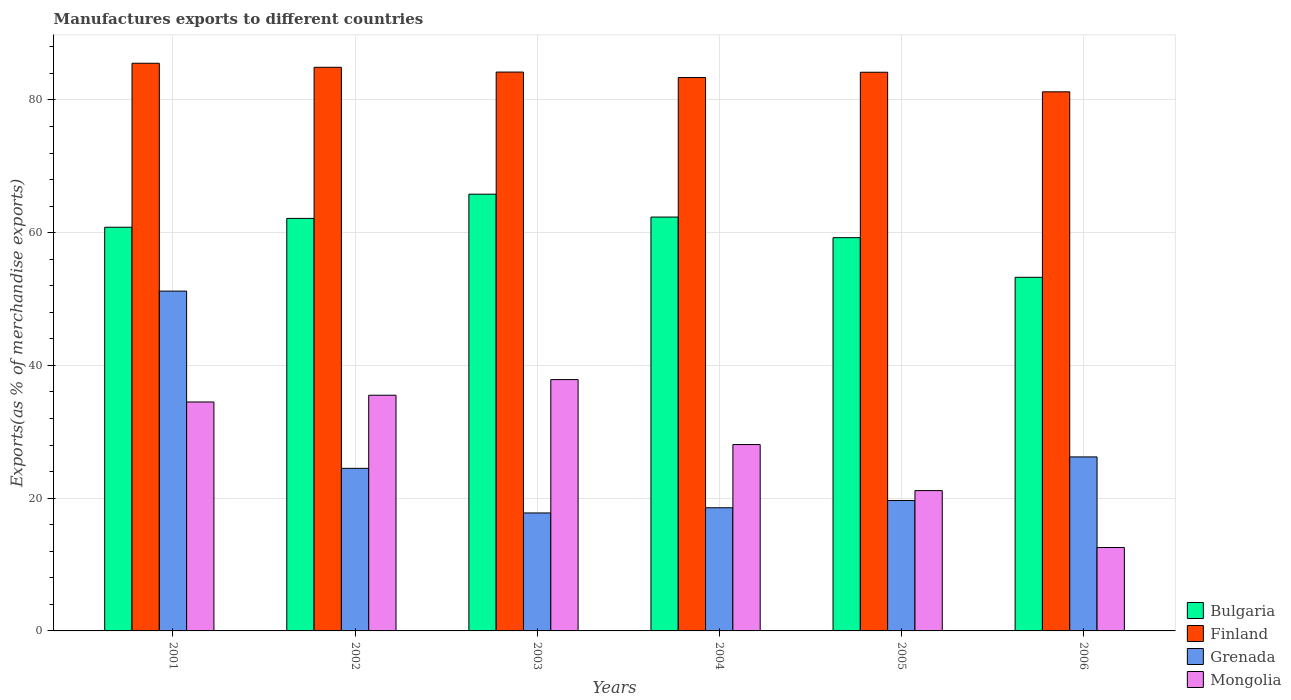How many different coloured bars are there?
Offer a terse response. 4. Are the number of bars per tick equal to the number of legend labels?
Your response must be concise. Yes. Are the number of bars on each tick of the X-axis equal?
Your answer should be very brief. Yes. How many bars are there on the 1st tick from the left?
Make the answer very short. 4. How many bars are there on the 6th tick from the right?
Offer a very short reply. 4. In how many cases, is the number of bars for a given year not equal to the number of legend labels?
Offer a very short reply. 0. What is the percentage of exports to different countries in Grenada in 2003?
Offer a very short reply. 17.77. Across all years, what is the maximum percentage of exports to different countries in Grenada?
Your answer should be compact. 51.2. Across all years, what is the minimum percentage of exports to different countries in Grenada?
Ensure brevity in your answer.  17.77. In which year was the percentage of exports to different countries in Bulgaria minimum?
Provide a succinct answer. 2006. What is the total percentage of exports to different countries in Mongolia in the graph?
Offer a very short reply. 169.65. What is the difference between the percentage of exports to different countries in Bulgaria in 2002 and that in 2006?
Provide a short and direct response. 8.88. What is the difference between the percentage of exports to different countries in Bulgaria in 2003 and the percentage of exports to different countries in Mongolia in 2002?
Your answer should be very brief. 30.29. What is the average percentage of exports to different countries in Finland per year?
Make the answer very short. 83.9. In the year 2002, what is the difference between the percentage of exports to different countries in Grenada and percentage of exports to different countries in Bulgaria?
Your answer should be compact. -37.66. What is the ratio of the percentage of exports to different countries in Finland in 2005 to that in 2006?
Provide a succinct answer. 1.04. Is the percentage of exports to different countries in Bulgaria in 2001 less than that in 2004?
Your answer should be compact. Yes. What is the difference between the highest and the second highest percentage of exports to different countries in Bulgaria?
Provide a succinct answer. 3.45. What is the difference between the highest and the lowest percentage of exports to different countries in Grenada?
Your answer should be compact. 33.42. In how many years, is the percentage of exports to different countries in Finland greater than the average percentage of exports to different countries in Finland taken over all years?
Your answer should be compact. 4. Is the sum of the percentage of exports to different countries in Finland in 2002 and 2003 greater than the maximum percentage of exports to different countries in Grenada across all years?
Offer a very short reply. Yes. Is it the case that in every year, the sum of the percentage of exports to different countries in Mongolia and percentage of exports to different countries in Grenada is greater than the sum of percentage of exports to different countries in Finland and percentage of exports to different countries in Bulgaria?
Your answer should be compact. No. What does the 3rd bar from the left in 2005 represents?
Provide a succinct answer. Grenada. Is it the case that in every year, the sum of the percentage of exports to different countries in Bulgaria and percentage of exports to different countries in Finland is greater than the percentage of exports to different countries in Mongolia?
Your answer should be compact. Yes. How many bars are there?
Offer a very short reply. 24. How many years are there in the graph?
Make the answer very short. 6. What is the difference between two consecutive major ticks on the Y-axis?
Your response must be concise. 20. Are the values on the major ticks of Y-axis written in scientific E-notation?
Give a very brief answer. No. Does the graph contain grids?
Provide a short and direct response. Yes. Where does the legend appear in the graph?
Make the answer very short. Bottom right. How many legend labels are there?
Your answer should be compact. 4. What is the title of the graph?
Offer a terse response. Manufactures exports to different countries. What is the label or title of the Y-axis?
Offer a very short reply. Exports(as % of merchandise exports). What is the Exports(as % of merchandise exports) in Bulgaria in 2001?
Your answer should be compact. 60.82. What is the Exports(as % of merchandise exports) in Finland in 2001?
Keep it short and to the point. 85.52. What is the Exports(as % of merchandise exports) of Grenada in 2001?
Your answer should be compact. 51.2. What is the Exports(as % of merchandise exports) in Mongolia in 2001?
Provide a succinct answer. 34.49. What is the Exports(as % of merchandise exports) of Bulgaria in 2002?
Ensure brevity in your answer.  62.15. What is the Exports(as % of merchandise exports) of Finland in 2002?
Provide a succinct answer. 84.92. What is the Exports(as % of merchandise exports) of Grenada in 2002?
Offer a terse response. 24.49. What is the Exports(as % of merchandise exports) in Mongolia in 2002?
Ensure brevity in your answer.  35.51. What is the Exports(as % of merchandise exports) of Bulgaria in 2003?
Offer a very short reply. 65.8. What is the Exports(as % of merchandise exports) of Finland in 2003?
Offer a very short reply. 84.2. What is the Exports(as % of merchandise exports) of Grenada in 2003?
Provide a short and direct response. 17.77. What is the Exports(as % of merchandise exports) in Mongolia in 2003?
Give a very brief answer. 37.86. What is the Exports(as % of merchandise exports) in Bulgaria in 2004?
Offer a very short reply. 62.35. What is the Exports(as % of merchandise exports) of Finland in 2004?
Ensure brevity in your answer.  83.37. What is the Exports(as % of merchandise exports) of Grenada in 2004?
Offer a very short reply. 18.56. What is the Exports(as % of merchandise exports) in Mongolia in 2004?
Ensure brevity in your answer.  28.08. What is the Exports(as % of merchandise exports) in Bulgaria in 2005?
Offer a terse response. 59.25. What is the Exports(as % of merchandise exports) in Finland in 2005?
Keep it short and to the point. 84.17. What is the Exports(as % of merchandise exports) in Grenada in 2005?
Ensure brevity in your answer.  19.65. What is the Exports(as % of merchandise exports) of Mongolia in 2005?
Provide a succinct answer. 21.14. What is the Exports(as % of merchandise exports) in Bulgaria in 2006?
Your answer should be very brief. 53.27. What is the Exports(as % of merchandise exports) in Finland in 2006?
Make the answer very short. 81.22. What is the Exports(as % of merchandise exports) in Grenada in 2006?
Give a very brief answer. 26.21. What is the Exports(as % of merchandise exports) of Mongolia in 2006?
Give a very brief answer. 12.57. Across all years, what is the maximum Exports(as % of merchandise exports) of Bulgaria?
Provide a succinct answer. 65.8. Across all years, what is the maximum Exports(as % of merchandise exports) of Finland?
Make the answer very short. 85.52. Across all years, what is the maximum Exports(as % of merchandise exports) in Grenada?
Give a very brief answer. 51.2. Across all years, what is the maximum Exports(as % of merchandise exports) in Mongolia?
Offer a very short reply. 37.86. Across all years, what is the minimum Exports(as % of merchandise exports) of Bulgaria?
Offer a very short reply. 53.27. Across all years, what is the minimum Exports(as % of merchandise exports) in Finland?
Make the answer very short. 81.22. Across all years, what is the minimum Exports(as % of merchandise exports) of Grenada?
Your answer should be very brief. 17.77. Across all years, what is the minimum Exports(as % of merchandise exports) in Mongolia?
Ensure brevity in your answer.  12.57. What is the total Exports(as % of merchandise exports) of Bulgaria in the graph?
Keep it short and to the point. 363.63. What is the total Exports(as % of merchandise exports) in Finland in the graph?
Ensure brevity in your answer.  503.4. What is the total Exports(as % of merchandise exports) in Grenada in the graph?
Make the answer very short. 157.88. What is the total Exports(as % of merchandise exports) in Mongolia in the graph?
Your answer should be compact. 169.65. What is the difference between the Exports(as % of merchandise exports) of Bulgaria in 2001 and that in 2002?
Provide a succinct answer. -1.33. What is the difference between the Exports(as % of merchandise exports) in Finland in 2001 and that in 2002?
Your answer should be very brief. 0.61. What is the difference between the Exports(as % of merchandise exports) of Grenada in 2001 and that in 2002?
Your answer should be compact. 26.7. What is the difference between the Exports(as % of merchandise exports) in Mongolia in 2001 and that in 2002?
Offer a very short reply. -1.02. What is the difference between the Exports(as % of merchandise exports) of Bulgaria in 2001 and that in 2003?
Offer a very short reply. -4.98. What is the difference between the Exports(as % of merchandise exports) in Finland in 2001 and that in 2003?
Your answer should be compact. 1.33. What is the difference between the Exports(as % of merchandise exports) in Grenada in 2001 and that in 2003?
Offer a very short reply. 33.42. What is the difference between the Exports(as % of merchandise exports) in Mongolia in 2001 and that in 2003?
Ensure brevity in your answer.  -3.37. What is the difference between the Exports(as % of merchandise exports) of Bulgaria in 2001 and that in 2004?
Your response must be concise. -1.53. What is the difference between the Exports(as % of merchandise exports) in Finland in 2001 and that in 2004?
Provide a short and direct response. 2.15. What is the difference between the Exports(as % of merchandise exports) in Grenada in 2001 and that in 2004?
Ensure brevity in your answer.  32.64. What is the difference between the Exports(as % of merchandise exports) in Mongolia in 2001 and that in 2004?
Provide a short and direct response. 6.41. What is the difference between the Exports(as % of merchandise exports) of Bulgaria in 2001 and that in 2005?
Your answer should be compact. 1.57. What is the difference between the Exports(as % of merchandise exports) of Finland in 2001 and that in 2005?
Your answer should be very brief. 1.35. What is the difference between the Exports(as % of merchandise exports) in Grenada in 2001 and that in 2005?
Give a very brief answer. 31.55. What is the difference between the Exports(as % of merchandise exports) in Mongolia in 2001 and that in 2005?
Make the answer very short. 13.35. What is the difference between the Exports(as % of merchandise exports) in Bulgaria in 2001 and that in 2006?
Keep it short and to the point. 7.54. What is the difference between the Exports(as % of merchandise exports) of Finland in 2001 and that in 2006?
Your answer should be very brief. 4.3. What is the difference between the Exports(as % of merchandise exports) of Grenada in 2001 and that in 2006?
Your response must be concise. 24.98. What is the difference between the Exports(as % of merchandise exports) of Mongolia in 2001 and that in 2006?
Provide a succinct answer. 21.93. What is the difference between the Exports(as % of merchandise exports) of Bulgaria in 2002 and that in 2003?
Offer a terse response. -3.65. What is the difference between the Exports(as % of merchandise exports) in Finland in 2002 and that in 2003?
Your answer should be very brief. 0.72. What is the difference between the Exports(as % of merchandise exports) of Grenada in 2002 and that in 2003?
Offer a terse response. 6.72. What is the difference between the Exports(as % of merchandise exports) in Mongolia in 2002 and that in 2003?
Ensure brevity in your answer.  -2.35. What is the difference between the Exports(as % of merchandise exports) in Bulgaria in 2002 and that in 2004?
Keep it short and to the point. -0.2. What is the difference between the Exports(as % of merchandise exports) in Finland in 2002 and that in 2004?
Keep it short and to the point. 1.54. What is the difference between the Exports(as % of merchandise exports) in Grenada in 2002 and that in 2004?
Your answer should be compact. 5.94. What is the difference between the Exports(as % of merchandise exports) of Mongolia in 2002 and that in 2004?
Ensure brevity in your answer.  7.43. What is the difference between the Exports(as % of merchandise exports) in Bulgaria in 2002 and that in 2005?
Make the answer very short. 2.9. What is the difference between the Exports(as % of merchandise exports) in Finland in 2002 and that in 2005?
Provide a short and direct response. 0.75. What is the difference between the Exports(as % of merchandise exports) in Grenada in 2002 and that in 2005?
Keep it short and to the point. 4.85. What is the difference between the Exports(as % of merchandise exports) of Mongolia in 2002 and that in 2005?
Provide a succinct answer. 14.37. What is the difference between the Exports(as % of merchandise exports) of Bulgaria in 2002 and that in 2006?
Make the answer very short. 8.88. What is the difference between the Exports(as % of merchandise exports) in Finland in 2002 and that in 2006?
Your answer should be very brief. 3.7. What is the difference between the Exports(as % of merchandise exports) in Grenada in 2002 and that in 2006?
Your response must be concise. -1.72. What is the difference between the Exports(as % of merchandise exports) of Mongolia in 2002 and that in 2006?
Offer a terse response. 22.94. What is the difference between the Exports(as % of merchandise exports) of Bulgaria in 2003 and that in 2004?
Give a very brief answer. 3.45. What is the difference between the Exports(as % of merchandise exports) of Finland in 2003 and that in 2004?
Keep it short and to the point. 0.82. What is the difference between the Exports(as % of merchandise exports) in Grenada in 2003 and that in 2004?
Your answer should be very brief. -0.78. What is the difference between the Exports(as % of merchandise exports) of Mongolia in 2003 and that in 2004?
Your answer should be very brief. 9.78. What is the difference between the Exports(as % of merchandise exports) of Bulgaria in 2003 and that in 2005?
Your answer should be very brief. 6.55. What is the difference between the Exports(as % of merchandise exports) of Finland in 2003 and that in 2005?
Your answer should be compact. 0.03. What is the difference between the Exports(as % of merchandise exports) of Grenada in 2003 and that in 2005?
Your answer should be very brief. -1.87. What is the difference between the Exports(as % of merchandise exports) of Mongolia in 2003 and that in 2005?
Your answer should be very brief. 16.72. What is the difference between the Exports(as % of merchandise exports) in Bulgaria in 2003 and that in 2006?
Your response must be concise. 12.52. What is the difference between the Exports(as % of merchandise exports) of Finland in 2003 and that in 2006?
Keep it short and to the point. 2.98. What is the difference between the Exports(as % of merchandise exports) of Grenada in 2003 and that in 2006?
Your response must be concise. -8.44. What is the difference between the Exports(as % of merchandise exports) in Mongolia in 2003 and that in 2006?
Keep it short and to the point. 25.3. What is the difference between the Exports(as % of merchandise exports) in Bulgaria in 2004 and that in 2005?
Your response must be concise. 3.1. What is the difference between the Exports(as % of merchandise exports) in Finland in 2004 and that in 2005?
Ensure brevity in your answer.  -0.8. What is the difference between the Exports(as % of merchandise exports) of Grenada in 2004 and that in 2005?
Offer a very short reply. -1.09. What is the difference between the Exports(as % of merchandise exports) of Mongolia in 2004 and that in 2005?
Provide a short and direct response. 6.94. What is the difference between the Exports(as % of merchandise exports) of Bulgaria in 2004 and that in 2006?
Your response must be concise. 9.08. What is the difference between the Exports(as % of merchandise exports) of Finland in 2004 and that in 2006?
Provide a succinct answer. 2.15. What is the difference between the Exports(as % of merchandise exports) of Grenada in 2004 and that in 2006?
Provide a short and direct response. -7.66. What is the difference between the Exports(as % of merchandise exports) in Mongolia in 2004 and that in 2006?
Your answer should be very brief. 15.51. What is the difference between the Exports(as % of merchandise exports) in Bulgaria in 2005 and that in 2006?
Your answer should be very brief. 5.97. What is the difference between the Exports(as % of merchandise exports) in Finland in 2005 and that in 2006?
Provide a succinct answer. 2.95. What is the difference between the Exports(as % of merchandise exports) in Grenada in 2005 and that in 2006?
Provide a succinct answer. -6.57. What is the difference between the Exports(as % of merchandise exports) of Mongolia in 2005 and that in 2006?
Provide a short and direct response. 8.57. What is the difference between the Exports(as % of merchandise exports) of Bulgaria in 2001 and the Exports(as % of merchandise exports) of Finland in 2002?
Provide a succinct answer. -24.1. What is the difference between the Exports(as % of merchandise exports) of Bulgaria in 2001 and the Exports(as % of merchandise exports) of Grenada in 2002?
Keep it short and to the point. 36.32. What is the difference between the Exports(as % of merchandise exports) of Bulgaria in 2001 and the Exports(as % of merchandise exports) of Mongolia in 2002?
Give a very brief answer. 25.31. What is the difference between the Exports(as % of merchandise exports) in Finland in 2001 and the Exports(as % of merchandise exports) in Grenada in 2002?
Your response must be concise. 61.03. What is the difference between the Exports(as % of merchandise exports) in Finland in 2001 and the Exports(as % of merchandise exports) in Mongolia in 2002?
Keep it short and to the point. 50.01. What is the difference between the Exports(as % of merchandise exports) of Grenada in 2001 and the Exports(as % of merchandise exports) of Mongolia in 2002?
Offer a terse response. 15.69. What is the difference between the Exports(as % of merchandise exports) in Bulgaria in 2001 and the Exports(as % of merchandise exports) in Finland in 2003?
Provide a short and direct response. -23.38. What is the difference between the Exports(as % of merchandise exports) of Bulgaria in 2001 and the Exports(as % of merchandise exports) of Grenada in 2003?
Offer a very short reply. 43.04. What is the difference between the Exports(as % of merchandise exports) of Bulgaria in 2001 and the Exports(as % of merchandise exports) of Mongolia in 2003?
Provide a succinct answer. 22.95. What is the difference between the Exports(as % of merchandise exports) of Finland in 2001 and the Exports(as % of merchandise exports) of Grenada in 2003?
Make the answer very short. 67.75. What is the difference between the Exports(as % of merchandise exports) in Finland in 2001 and the Exports(as % of merchandise exports) in Mongolia in 2003?
Your answer should be compact. 47.66. What is the difference between the Exports(as % of merchandise exports) of Grenada in 2001 and the Exports(as % of merchandise exports) of Mongolia in 2003?
Your response must be concise. 13.33. What is the difference between the Exports(as % of merchandise exports) in Bulgaria in 2001 and the Exports(as % of merchandise exports) in Finland in 2004?
Your answer should be compact. -22.56. What is the difference between the Exports(as % of merchandise exports) in Bulgaria in 2001 and the Exports(as % of merchandise exports) in Grenada in 2004?
Keep it short and to the point. 42.26. What is the difference between the Exports(as % of merchandise exports) in Bulgaria in 2001 and the Exports(as % of merchandise exports) in Mongolia in 2004?
Offer a terse response. 32.74. What is the difference between the Exports(as % of merchandise exports) in Finland in 2001 and the Exports(as % of merchandise exports) in Grenada in 2004?
Offer a very short reply. 66.97. What is the difference between the Exports(as % of merchandise exports) of Finland in 2001 and the Exports(as % of merchandise exports) of Mongolia in 2004?
Ensure brevity in your answer.  57.44. What is the difference between the Exports(as % of merchandise exports) of Grenada in 2001 and the Exports(as % of merchandise exports) of Mongolia in 2004?
Keep it short and to the point. 23.12. What is the difference between the Exports(as % of merchandise exports) in Bulgaria in 2001 and the Exports(as % of merchandise exports) in Finland in 2005?
Your answer should be compact. -23.35. What is the difference between the Exports(as % of merchandise exports) in Bulgaria in 2001 and the Exports(as % of merchandise exports) in Grenada in 2005?
Keep it short and to the point. 41.17. What is the difference between the Exports(as % of merchandise exports) in Bulgaria in 2001 and the Exports(as % of merchandise exports) in Mongolia in 2005?
Offer a terse response. 39.68. What is the difference between the Exports(as % of merchandise exports) in Finland in 2001 and the Exports(as % of merchandise exports) in Grenada in 2005?
Keep it short and to the point. 65.88. What is the difference between the Exports(as % of merchandise exports) in Finland in 2001 and the Exports(as % of merchandise exports) in Mongolia in 2005?
Your answer should be compact. 64.38. What is the difference between the Exports(as % of merchandise exports) of Grenada in 2001 and the Exports(as % of merchandise exports) of Mongolia in 2005?
Keep it short and to the point. 30.05. What is the difference between the Exports(as % of merchandise exports) in Bulgaria in 2001 and the Exports(as % of merchandise exports) in Finland in 2006?
Your answer should be compact. -20.4. What is the difference between the Exports(as % of merchandise exports) of Bulgaria in 2001 and the Exports(as % of merchandise exports) of Grenada in 2006?
Provide a short and direct response. 34.6. What is the difference between the Exports(as % of merchandise exports) of Bulgaria in 2001 and the Exports(as % of merchandise exports) of Mongolia in 2006?
Your answer should be compact. 48.25. What is the difference between the Exports(as % of merchandise exports) of Finland in 2001 and the Exports(as % of merchandise exports) of Grenada in 2006?
Your response must be concise. 59.31. What is the difference between the Exports(as % of merchandise exports) in Finland in 2001 and the Exports(as % of merchandise exports) in Mongolia in 2006?
Provide a succinct answer. 72.96. What is the difference between the Exports(as % of merchandise exports) of Grenada in 2001 and the Exports(as % of merchandise exports) of Mongolia in 2006?
Offer a terse response. 38.63. What is the difference between the Exports(as % of merchandise exports) of Bulgaria in 2002 and the Exports(as % of merchandise exports) of Finland in 2003?
Ensure brevity in your answer.  -22.05. What is the difference between the Exports(as % of merchandise exports) in Bulgaria in 2002 and the Exports(as % of merchandise exports) in Grenada in 2003?
Ensure brevity in your answer.  44.38. What is the difference between the Exports(as % of merchandise exports) of Bulgaria in 2002 and the Exports(as % of merchandise exports) of Mongolia in 2003?
Your response must be concise. 24.29. What is the difference between the Exports(as % of merchandise exports) of Finland in 2002 and the Exports(as % of merchandise exports) of Grenada in 2003?
Your response must be concise. 67.14. What is the difference between the Exports(as % of merchandise exports) in Finland in 2002 and the Exports(as % of merchandise exports) in Mongolia in 2003?
Offer a very short reply. 47.05. What is the difference between the Exports(as % of merchandise exports) in Grenada in 2002 and the Exports(as % of merchandise exports) in Mongolia in 2003?
Make the answer very short. -13.37. What is the difference between the Exports(as % of merchandise exports) in Bulgaria in 2002 and the Exports(as % of merchandise exports) in Finland in 2004?
Make the answer very short. -21.22. What is the difference between the Exports(as % of merchandise exports) of Bulgaria in 2002 and the Exports(as % of merchandise exports) of Grenada in 2004?
Provide a succinct answer. 43.59. What is the difference between the Exports(as % of merchandise exports) in Bulgaria in 2002 and the Exports(as % of merchandise exports) in Mongolia in 2004?
Offer a terse response. 34.07. What is the difference between the Exports(as % of merchandise exports) in Finland in 2002 and the Exports(as % of merchandise exports) in Grenada in 2004?
Make the answer very short. 66.36. What is the difference between the Exports(as % of merchandise exports) of Finland in 2002 and the Exports(as % of merchandise exports) of Mongolia in 2004?
Offer a very short reply. 56.84. What is the difference between the Exports(as % of merchandise exports) in Grenada in 2002 and the Exports(as % of merchandise exports) in Mongolia in 2004?
Your answer should be compact. -3.59. What is the difference between the Exports(as % of merchandise exports) of Bulgaria in 2002 and the Exports(as % of merchandise exports) of Finland in 2005?
Keep it short and to the point. -22.02. What is the difference between the Exports(as % of merchandise exports) in Bulgaria in 2002 and the Exports(as % of merchandise exports) in Grenada in 2005?
Provide a short and direct response. 42.5. What is the difference between the Exports(as % of merchandise exports) in Bulgaria in 2002 and the Exports(as % of merchandise exports) in Mongolia in 2005?
Keep it short and to the point. 41.01. What is the difference between the Exports(as % of merchandise exports) in Finland in 2002 and the Exports(as % of merchandise exports) in Grenada in 2005?
Your answer should be very brief. 65.27. What is the difference between the Exports(as % of merchandise exports) in Finland in 2002 and the Exports(as % of merchandise exports) in Mongolia in 2005?
Give a very brief answer. 63.77. What is the difference between the Exports(as % of merchandise exports) in Grenada in 2002 and the Exports(as % of merchandise exports) in Mongolia in 2005?
Make the answer very short. 3.35. What is the difference between the Exports(as % of merchandise exports) of Bulgaria in 2002 and the Exports(as % of merchandise exports) of Finland in 2006?
Ensure brevity in your answer.  -19.07. What is the difference between the Exports(as % of merchandise exports) of Bulgaria in 2002 and the Exports(as % of merchandise exports) of Grenada in 2006?
Give a very brief answer. 35.93. What is the difference between the Exports(as % of merchandise exports) of Bulgaria in 2002 and the Exports(as % of merchandise exports) of Mongolia in 2006?
Your answer should be very brief. 49.58. What is the difference between the Exports(as % of merchandise exports) of Finland in 2002 and the Exports(as % of merchandise exports) of Grenada in 2006?
Give a very brief answer. 58.7. What is the difference between the Exports(as % of merchandise exports) of Finland in 2002 and the Exports(as % of merchandise exports) of Mongolia in 2006?
Offer a very short reply. 72.35. What is the difference between the Exports(as % of merchandise exports) in Grenada in 2002 and the Exports(as % of merchandise exports) in Mongolia in 2006?
Give a very brief answer. 11.93. What is the difference between the Exports(as % of merchandise exports) in Bulgaria in 2003 and the Exports(as % of merchandise exports) in Finland in 2004?
Provide a succinct answer. -17.57. What is the difference between the Exports(as % of merchandise exports) of Bulgaria in 2003 and the Exports(as % of merchandise exports) of Grenada in 2004?
Your response must be concise. 47.24. What is the difference between the Exports(as % of merchandise exports) in Bulgaria in 2003 and the Exports(as % of merchandise exports) in Mongolia in 2004?
Ensure brevity in your answer.  37.72. What is the difference between the Exports(as % of merchandise exports) of Finland in 2003 and the Exports(as % of merchandise exports) of Grenada in 2004?
Offer a terse response. 65.64. What is the difference between the Exports(as % of merchandise exports) in Finland in 2003 and the Exports(as % of merchandise exports) in Mongolia in 2004?
Keep it short and to the point. 56.12. What is the difference between the Exports(as % of merchandise exports) of Grenada in 2003 and the Exports(as % of merchandise exports) of Mongolia in 2004?
Your answer should be very brief. -10.31. What is the difference between the Exports(as % of merchandise exports) of Bulgaria in 2003 and the Exports(as % of merchandise exports) of Finland in 2005?
Offer a very short reply. -18.37. What is the difference between the Exports(as % of merchandise exports) of Bulgaria in 2003 and the Exports(as % of merchandise exports) of Grenada in 2005?
Keep it short and to the point. 46.15. What is the difference between the Exports(as % of merchandise exports) of Bulgaria in 2003 and the Exports(as % of merchandise exports) of Mongolia in 2005?
Keep it short and to the point. 44.66. What is the difference between the Exports(as % of merchandise exports) of Finland in 2003 and the Exports(as % of merchandise exports) of Grenada in 2005?
Make the answer very short. 64.55. What is the difference between the Exports(as % of merchandise exports) in Finland in 2003 and the Exports(as % of merchandise exports) in Mongolia in 2005?
Ensure brevity in your answer.  63.06. What is the difference between the Exports(as % of merchandise exports) in Grenada in 2003 and the Exports(as % of merchandise exports) in Mongolia in 2005?
Offer a very short reply. -3.37. What is the difference between the Exports(as % of merchandise exports) in Bulgaria in 2003 and the Exports(as % of merchandise exports) in Finland in 2006?
Offer a terse response. -15.42. What is the difference between the Exports(as % of merchandise exports) in Bulgaria in 2003 and the Exports(as % of merchandise exports) in Grenada in 2006?
Your answer should be compact. 39.58. What is the difference between the Exports(as % of merchandise exports) in Bulgaria in 2003 and the Exports(as % of merchandise exports) in Mongolia in 2006?
Make the answer very short. 53.23. What is the difference between the Exports(as % of merchandise exports) in Finland in 2003 and the Exports(as % of merchandise exports) in Grenada in 2006?
Keep it short and to the point. 57.98. What is the difference between the Exports(as % of merchandise exports) of Finland in 2003 and the Exports(as % of merchandise exports) of Mongolia in 2006?
Offer a terse response. 71.63. What is the difference between the Exports(as % of merchandise exports) of Grenada in 2003 and the Exports(as % of merchandise exports) of Mongolia in 2006?
Provide a succinct answer. 5.21. What is the difference between the Exports(as % of merchandise exports) in Bulgaria in 2004 and the Exports(as % of merchandise exports) in Finland in 2005?
Provide a succinct answer. -21.82. What is the difference between the Exports(as % of merchandise exports) in Bulgaria in 2004 and the Exports(as % of merchandise exports) in Grenada in 2005?
Your answer should be compact. 42.7. What is the difference between the Exports(as % of merchandise exports) in Bulgaria in 2004 and the Exports(as % of merchandise exports) in Mongolia in 2005?
Keep it short and to the point. 41.21. What is the difference between the Exports(as % of merchandise exports) of Finland in 2004 and the Exports(as % of merchandise exports) of Grenada in 2005?
Your answer should be compact. 63.73. What is the difference between the Exports(as % of merchandise exports) in Finland in 2004 and the Exports(as % of merchandise exports) in Mongolia in 2005?
Provide a succinct answer. 62.23. What is the difference between the Exports(as % of merchandise exports) of Grenada in 2004 and the Exports(as % of merchandise exports) of Mongolia in 2005?
Your response must be concise. -2.59. What is the difference between the Exports(as % of merchandise exports) of Bulgaria in 2004 and the Exports(as % of merchandise exports) of Finland in 2006?
Offer a very short reply. -18.87. What is the difference between the Exports(as % of merchandise exports) in Bulgaria in 2004 and the Exports(as % of merchandise exports) in Grenada in 2006?
Make the answer very short. 36.14. What is the difference between the Exports(as % of merchandise exports) in Bulgaria in 2004 and the Exports(as % of merchandise exports) in Mongolia in 2006?
Give a very brief answer. 49.78. What is the difference between the Exports(as % of merchandise exports) of Finland in 2004 and the Exports(as % of merchandise exports) of Grenada in 2006?
Your answer should be compact. 57.16. What is the difference between the Exports(as % of merchandise exports) in Finland in 2004 and the Exports(as % of merchandise exports) in Mongolia in 2006?
Your answer should be very brief. 70.8. What is the difference between the Exports(as % of merchandise exports) of Grenada in 2004 and the Exports(as % of merchandise exports) of Mongolia in 2006?
Your answer should be compact. 5.99. What is the difference between the Exports(as % of merchandise exports) in Bulgaria in 2005 and the Exports(as % of merchandise exports) in Finland in 2006?
Your answer should be compact. -21.97. What is the difference between the Exports(as % of merchandise exports) in Bulgaria in 2005 and the Exports(as % of merchandise exports) in Grenada in 2006?
Ensure brevity in your answer.  33.03. What is the difference between the Exports(as % of merchandise exports) of Bulgaria in 2005 and the Exports(as % of merchandise exports) of Mongolia in 2006?
Make the answer very short. 46.68. What is the difference between the Exports(as % of merchandise exports) of Finland in 2005 and the Exports(as % of merchandise exports) of Grenada in 2006?
Offer a very short reply. 57.96. What is the difference between the Exports(as % of merchandise exports) of Finland in 2005 and the Exports(as % of merchandise exports) of Mongolia in 2006?
Provide a succinct answer. 71.6. What is the difference between the Exports(as % of merchandise exports) of Grenada in 2005 and the Exports(as % of merchandise exports) of Mongolia in 2006?
Keep it short and to the point. 7.08. What is the average Exports(as % of merchandise exports) in Bulgaria per year?
Your answer should be very brief. 60.61. What is the average Exports(as % of merchandise exports) in Finland per year?
Provide a succinct answer. 83.9. What is the average Exports(as % of merchandise exports) of Grenada per year?
Keep it short and to the point. 26.31. What is the average Exports(as % of merchandise exports) in Mongolia per year?
Ensure brevity in your answer.  28.28. In the year 2001, what is the difference between the Exports(as % of merchandise exports) in Bulgaria and Exports(as % of merchandise exports) in Finland?
Provide a short and direct response. -24.71. In the year 2001, what is the difference between the Exports(as % of merchandise exports) in Bulgaria and Exports(as % of merchandise exports) in Grenada?
Your answer should be very brief. 9.62. In the year 2001, what is the difference between the Exports(as % of merchandise exports) in Bulgaria and Exports(as % of merchandise exports) in Mongolia?
Give a very brief answer. 26.32. In the year 2001, what is the difference between the Exports(as % of merchandise exports) of Finland and Exports(as % of merchandise exports) of Grenada?
Provide a succinct answer. 34.33. In the year 2001, what is the difference between the Exports(as % of merchandise exports) in Finland and Exports(as % of merchandise exports) in Mongolia?
Offer a very short reply. 51.03. In the year 2001, what is the difference between the Exports(as % of merchandise exports) in Grenada and Exports(as % of merchandise exports) in Mongolia?
Provide a short and direct response. 16.7. In the year 2002, what is the difference between the Exports(as % of merchandise exports) of Bulgaria and Exports(as % of merchandise exports) of Finland?
Ensure brevity in your answer.  -22.77. In the year 2002, what is the difference between the Exports(as % of merchandise exports) in Bulgaria and Exports(as % of merchandise exports) in Grenada?
Your answer should be compact. 37.66. In the year 2002, what is the difference between the Exports(as % of merchandise exports) in Bulgaria and Exports(as % of merchandise exports) in Mongolia?
Make the answer very short. 26.64. In the year 2002, what is the difference between the Exports(as % of merchandise exports) in Finland and Exports(as % of merchandise exports) in Grenada?
Make the answer very short. 60.42. In the year 2002, what is the difference between the Exports(as % of merchandise exports) in Finland and Exports(as % of merchandise exports) in Mongolia?
Make the answer very short. 49.41. In the year 2002, what is the difference between the Exports(as % of merchandise exports) in Grenada and Exports(as % of merchandise exports) in Mongolia?
Your response must be concise. -11.02. In the year 2003, what is the difference between the Exports(as % of merchandise exports) in Bulgaria and Exports(as % of merchandise exports) in Finland?
Provide a succinct answer. -18.4. In the year 2003, what is the difference between the Exports(as % of merchandise exports) of Bulgaria and Exports(as % of merchandise exports) of Grenada?
Offer a very short reply. 48.02. In the year 2003, what is the difference between the Exports(as % of merchandise exports) of Bulgaria and Exports(as % of merchandise exports) of Mongolia?
Your answer should be compact. 27.93. In the year 2003, what is the difference between the Exports(as % of merchandise exports) in Finland and Exports(as % of merchandise exports) in Grenada?
Ensure brevity in your answer.  66.42. In the year 2003, what is the difference between the Exports(as % of merchandise exports) of Finland and Exports(as % of merchandise exports) of Mongolia?
Your answer should be compact. 46.33. In the year 2003, what is the difference between the Exports(as % of merchandise exports) of Grenada and Exports(as % of merchandise exports) of Mongolia?
Keep it short and to the point. -20.09. In the year 2004, what is the difference between the Exports(as % of merchandise exports) of Bulgaria and Exports(as % of merchandise exports) of Finland?
Provide a short and direct response. -21.02. In the year 2004, what is the difference between the Exports(as % of merchandise exports) of Bulgaria and Exports(as % of merchandise exports) of Grenada?
Offer a very short reply. 43.8. In the year 2004, what is the difference between the Exports(as % of merchandise exports) of Bulgaria and Exports(as % of merchandise exports) of Mongolia?
Give a very brief answer. 34.27. In the year 2004, what is the difference between the Exports(as % of merchandise exports) in Finland and Exports(as % of merchandise exports) in Grenada?
Offer a very short reply. 64.82. In the year 2004, what is the difference between the Exports(as % of merchandise exports) in Finland and Exports(as % of merchandise exports) in Mongolia?
Provide a short and direct response. 55.29. In the year 2004, what is the difference between the Exports(as % of merchandise exports) in Grenada and Exports(as % of merchandise exports) in Mongolia?
Ensure brevity in your answer.  -9.52. In the year 2005, what is the difference between the Exports(as % of merchandise exports) of Bulgaria and Exports(as % of merchandise exports) of Finland?
Provide a succinct answer. -24.92. In the year 2005, what is the difference between the Exports(as % of merchandise exports) in Bulgaria and Exports(as % of merchandise exports) in Grenada?
Your answer should be very brief. 39.6. In the year 2005, what is the difference between the Exports(as % of merchandise exports) of Bulgaria and Exports(as % of merchandise exports) of Mongolia?
Your response must be concise. 38.11. In the year 2005, what is the difference between the Exports(as % of merchandise exports) in Finland and Exports(as % of merchandise exports) in Grenada?
Your response must be concise. 64.52. In the year 2005, what is the difference between the Exports(as % of merchandise exports) in Finland and Exports(as % of merchandise exports) in Mongolia?
Offer a very short reply. 63.03. In the year 2005, what is the difference between the Exports(as % of merchandise exports) of Grenada and Exports(as % of merchandise exports) of Mongolia?
Your response must be concise. -1.5. In the year 2006, what is the difference between the Exports(as % of merchandise exports) in Bulgaria and Exports(as % of merchandise exports) in Finland?
Make the answer very short. -27.94. In the year 2006, what is the difference between the Exports(as % of merchandise exports) of Bulgaria and Exports(as % of merchandise exports) of Grenada?
Ensure brevity in your answer.  27.06. In the year 2006, what is the difference between the Exports(as % of merchandise exports) in Bulgaria and Exports(as % of merchandise exports) in Mongolia?
Give a very brief answer. 40.71. In the year 2006, what is the difference between the Exports(as % of merchandise exports) in Finland and Exports(as % of merchandise exports) in Grenada?
Offer a terse response. 55. In the year 2006, what is the difference between the Exports(as % of merchandise exports) of Finland and Exports(as % of merchandise exports) of Mongolia?
Provide a short and direct response. 68.65. In the year 2006, what is the difference between the Exports(as % of merchandise exports) of Grenada and Exports(as % of merchandise exports) of Mongolia?
Your answer should be compact. 13.65. What is the ratio of the Exports(as % of merchandise exports) in Bulgaria in 2001 to that in 2002?
Your response must be concise. 0.98. What is the ratio of the Exports(as % of merchandise exports) in Finland in 2001 to that in 2002?
Provide a short and direct response. 1.01. What is the ratio of the Exports(as % of merchandise exports) in Grenada in 2001 to that in 2002?
Give a very brief answer. 2.09. What is the ratio of the Exports(as % of merchandise exports) in Mongolia in 2001 to that in 2002?
Provide a short and direct response. 0.97. What is the ratio of the Exports(as % of merchandise exports) in Bulgaria in 2001 to that in 2003?
Your response must be concise. 0.92. What is the ratio of the Exports(as % of merchandise exports) of Finland in 2001 to that in 2003?
Offer a terse response. 1.02. What is the ratio of the Exports(as % of merchandise exports) in Grenada in 2001 to that in 2003?
Give a very brief answer. 2.88. What is the ratio of the Exports(as % of merchandise exports) in Mongolia in 2001 to that in 2003?
Provide a succinct answer. 0.91. What is the ratio of the Exports(as % of merchandise exports) of Bulgaria in 2001 to that in 2004?
Ensure brevity in your answer.  0.98. What is the ratio of the Exports(as % of merchandise exports) of Finland in 2001 to that in 2004?
Your answer should be compact. 1.03. What is the ratio of the Exports(as % of merchandise exports) of Grenada in 2001 to that in 2004?
Offer a terse response. 2.76. What is the ratio of the Exports(as % of merchandise exports) in Mongolia in 2001 to that in 2004?
Ensure brevity in your answer.  1.23. What is the ratio of the Exports(as % of merchandise exports) in Bulgaria in 2001 to that in 2005?
Offer a very short reply. 1.03. What is the ratio of the Exports(as % of merchandise exports) of Finland in 2001 to that in 2005?
Give a very brief answer. 1.02. What is the ratio of the Exports(as % of merchandise exports) of Grenada in 2001 to that in 2005?
Ensure brevity in your answer.  2.61. What is the ratio of the Exports(as % of merchandise exports) of Mongolia in 2001 to that in 2005?
Make the answer very short. 1.63. What is the ratio of the Exports(as % of merchandise exports) of Bulgaria in 2001 to that in 2006?
Provide a short and direct response. 1.14. What is the ratio of the Exports(as % of merchandise exports) of Finland in 2001 to that in 2006?
Ensure brevity in your answer.  1.05. What is the ratio of the Exports(as % of merchandise exports) in Grenada in 2001 to that in 2006?
Make the answer very short. 1.95. What is the ratio of the Exports(as % of merchandise exports) in Mongolia in 2001 to that in 2006?
Offer a very short reply. 2.74. What is the ratio of the Exports(as % of merchandise exports) of Bulgaria in 2002 to that in 2003?
Give a very brief answer. 0.94. What is the ratio of the Exports(as % of merchandise exports) of Finland in 2002 to that in 2003?
Offer a terse response. 1.01. What is the ratio of the Exports(as % of merchandise exports) in Grenada in 2002 to that in 2003?
Make the answer very short. 1.38. What is the ratio of the Exports(as % of merchandise exports) of Mongolia in 2002 to that in 2003?
Offer a very short reply. 0.94. What is the ratio of the Exports(as % of merchandise exports) of Finland in 2002 to that in 2004?
Offer a very short reply. 1.02. What is the ratio of the Exports(as % of merchandise exports) of Grenada in 2002 to that in 2004?
Ensure brevity in your answer.  1.32. What is the ratio of the Exports(as % of merchandise exports) of Mongolia in 2002 to that in 2004?
Your answer should be compact. 1.26. What is the ratio of the Exports(as % of merchandise exports) of Bulgaria in 2002 to that in 2005?
Ensure brevity in your answer.  1.05. What is the ratio of the Exports(as % of merchandise exports) of Finland in 2002 to that in 2005?
Keep it short and to the point. 1.01. What is the ratio of the Exports(as % of merchandise exports) of Grenada in 2002 to that in 2005?
Provide a succinct answer. 1.25. What is the ratio of the Exports(as % of merchandise exports) in Mongolia in 2002 to that in 2005?
Offer a terse response. 1.68. What is the ratio of the Exports(as % of merchandise exports) of Bulgaria in 2002 to that in 2006?
Your answer should be compact. 1.17. What is the ratio of the Exports(as % of merchandise exports) of Finland in 2002 to that in 2006?
Your answer should be compact. 1.05. What is the ratio of the Exports(as % of merchandise exports) in Grenada in 2002 to that in 2006?
Your answer should be compact. 0.93. What is the ratio of the Exports(as % of merchandise exports) in Mongolia in 2002 to that in 2006?
Ensure brevity in your answer.  2.83. What is the ratio of the Exports(as % of merchandise exports) of Bulgaria in 2003 to that in 2004?
Give a very brief answer. 1.06. What is the ratio of the Exports(as % of merchandise exports) in Finland in 2003 to that in 2004?
Give a very brief answer. 1.01. What is the ratio of the Exports(as % of merchandise exports) of Grenada in 2003 to that in 2004?
Make the answer very short. 0.96. What is the ratio of the Exports(as % of merchandise exports) in Mongolia in 2003 to that in 2004?
Your response must be concise. 1.35. What is the ratio of the Exports(as % of merchandise exports) in Bulgaria in 2003 to that in 2005?
Offer a terse response. 1.11. What is the ratio of the Exports(as % of merchandise exports) of Grenada in 2003 to that in 2005?
Your response must be concise. 0.9. What is the ratio of the Exports(as % of merchandise exports) of Mongolia in 2003 to that in 2005?
Your answer should be very brief. 1.79. What is the ratio of the Exports(as % of merchandise exports) of Bulgaria in 2003 to that in 2006?
Offer a very short reply. 1.24. What is the ratio of the Exports(as % of merchandise exports) of Finland in 2003 to that in 2006?
Your answer should be compact. 1.04. What is the ratio of the Exports(as % of merchandise exports) in Grenada in 2003 to that in 2006?
Provide a succinct answer. 0.68. What is the ratio of the Exports(as % of merchandise exports) of Mongolia in 2003 to that in 2006?
Your answer should be compact. 3.01. What is the ratio of the Exports(as % of merchandise exports) in Bulgaria in 2004 to that in 2005?
Your response must be concise. 1.05. What is the ratio of the Exports(as % of merchandise exports) of Finland in 2004 to that in 2005?
Provide a succinct answer. 0.99. What is the ratio of the Exports(as % of merchandise exports) in Grenada in 2004 to that in 2005?
Keep it short and to the point. 0.94. What is the ratio of the Exports(as % of merchandise exports) of Mongolia in 2004 to that in 2005?
Make the answer very short. 1.33. What is the ratio of the Exports(as % of merchandise exports) in Bulgaria in 2004 to that in 2006?
Provide a short and direct response. 1.17. What is the ratio of the Exports(as % of merchandise exports) in Finland in 2004 to that in 2006?
Provide a succinct answer. 1.03. What is the ratio of the Exports(as % of merchandise exports) in Grenada in 2004 to that in 2006?
Keep it short and to the point. 0.71. What is the ratio of the Exports(as % of merchandise exports) of Mongolia in 2004 to that in 2006?
Provide a succinct answer. 2.23. What is the ratio of the Exports(as % of merchandise exports) of Bulgaria in 2005 to that in 2006?
Your answer should be compact. 1.11. What is the ratio of the Exports(as % of merchandise exports) of Finland in 2005 to that in 2006?
Provide a succinct answer. 1.04. What is the ratio of the Exports(as % of merchandise exports) of Grenada in 2005 to that in 2006?
Your answer should be very brief. 0.75. What is the ratio of the Exports(as % of merchandise exports) in Mongolia in 2005 to that in 2006?
Make the answer very short. 1.68. What is the difference between the highest and the second highest Exports(as % of merchandise exports) of Bulgaria?
Provide a short and direct response. 3.45. What is the difference between the highest and the second highest Exports(as % of merchandise exports) of Finland?
Offer a very short reply. 0.61. What is the difference between the highest and the second highest Exports(as % of merchandise exports) of Grenada?
Make the answer very short. 24.98. What is the difference between the highest and the second highest Exports(as % of merchandise exports) of Mongolia?
Provide a short and direct response. 2.35. What is the difference between the highest and the lowest Exports(as % of merchandise exports) of Bulgaria?
Offer a terse response. 12.52. What is the difference between the highest and the lowest Exports(as % of merchandise exports) of Finland?
Give a very brief answer. 4.3. What is the difference between the highest and the lowest Exports(as % of merchandise exports) in Grenada?
Provide a short and direct response. 33.42. What is the difference between the highest and the lowest Exports(as % of merchandise exports) in Mongolia?
Ensure brevity in your answer.  25.3. 